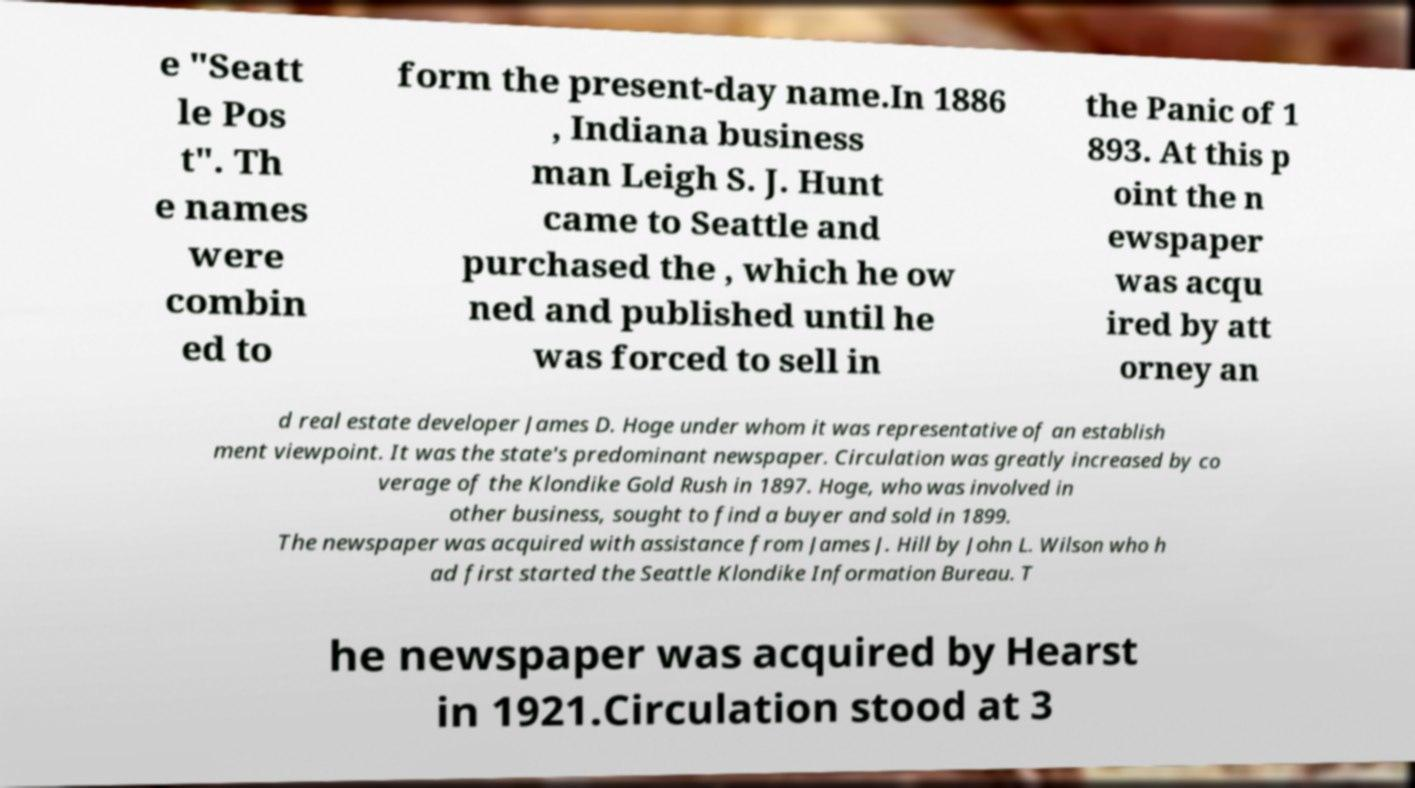There's text embedded in this image that I need extracted. Can you transcribe it verbatim? e "Seatt le Pos t". Th e names were combin ed to form the present-day name.In 1886 , Indiana business man Leigh S. J. Hunt came to Seattle and purchased the , which he ow ned and published until he was forced to sell in the Panic of 1 893. At this p oint the n ewspaper was acqu ired by att orney an d real estate developer James D. Hoge under whom it was representative of an establish ment viewpoint. It was the state's predominant newspaper. Circulation was greatly increased by co verage of the Klondike Gold Rush in 1897. Hoge, who was involved in other business, sought to find a buyer and sold in 1899. The newspaper was acquired with assistance from James J. Hill by John L. Wilson who h ad first started the Seattle Klondike Information Bureau. T he newspaper was acquired by Hearst in 1921.Circulation stood at 3 